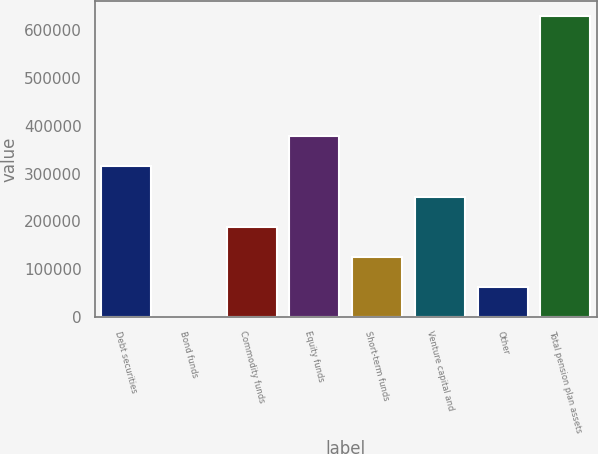Convert chart to OTSL. <chart><loc_0><loc_0><loc_500><loc_500><bar_chart><fcel>Debt securities<fcel>Bond funds<fcel>Commodity funds<fcel>Equity funds<fcel>Short-term funds<fcel>Venture capital and<fcel>Other<fcel>Total pension plan assets<nl><fcel>315152<fcel>2<fcel>189092<fcel>378183<fcel>126062<fcel>252122<fcel>63032.1<fcel>630303<nl></chart> 